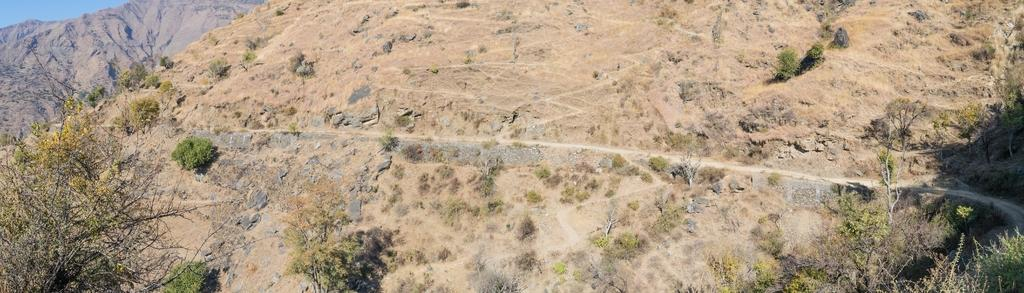What type of vegetation can be seen in the image? There are shrubs and trees in the image. What geographical feature is visible in the background of the image? The mountains are visible in the image. Is there a designated route for walking or hiking in the image? Yes, there is a pathway in the image. What part of the natural environment is visible in the image? The sky is visible in the image. What type of drink is being served in the image? There is no drink present in the image; it features shrubs, trees, mountains, a pathway, and the sky. What type of pleasure can be seen in the image? The image does not depict any specific pleasure or activity; it simply shows natural elements like shrubs, trees, mountains, a pathway, and the sky. 